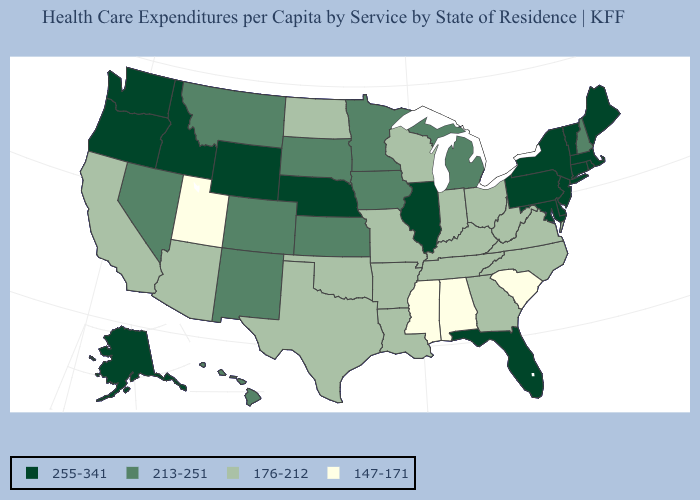What is the lowest value in the USA?
Write a very short answer. 147-171. What is the value of Alaska?
Answer briefly. 255-341. What is the highest value in states that border Missouri?
Write a very short answer. 255-341. What is the value of Connecticut?
Write a very short answer. 255-341. Does South Carolina have a lower value than Alabama?
Give a very brief answer. No. What is the value of Montana?
Be succinct. 213-251. What is the value of Kentucky?
Be succinct. 176-212. Name the states that have a value in the range 147-171?
Give a very brief answer. Alabama, Mississippi, South Carolina, Utah. What is the highest value in the Northeast ?
Write a very short answer. 255-341. Does the map have missing data?
Concise answer only. No. Name the states that have a value in the range 147-171?
Answer briefly. Alabama, Mississippi, South Carolina, Utah. What is the value of Nevada?
Be succinct. 213-251. Name the states that have a value in the range 213-251?
Give a very brief answer. Colorado, Hawaii, Iowa, Kansas, Michigan, Minnesota, Montana, Nevada, New Hampshire, New Mexico, South Dakota. Does Alaska have the same value as New Jersey?
Write a very short answer. Yes. 